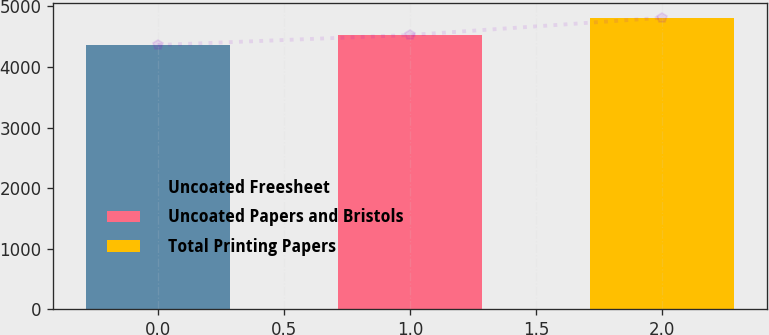Convert chart. <chart><loc_0><loc_0><loc_500><loc_500><bar_chart><fcel>Uncoated Freesheet<fcel>Uncoated Papers and Bristols<fcel>Total Printing Papers<nl><fcel>4362<fcel>4527<fcel>4812<nl></chart> 